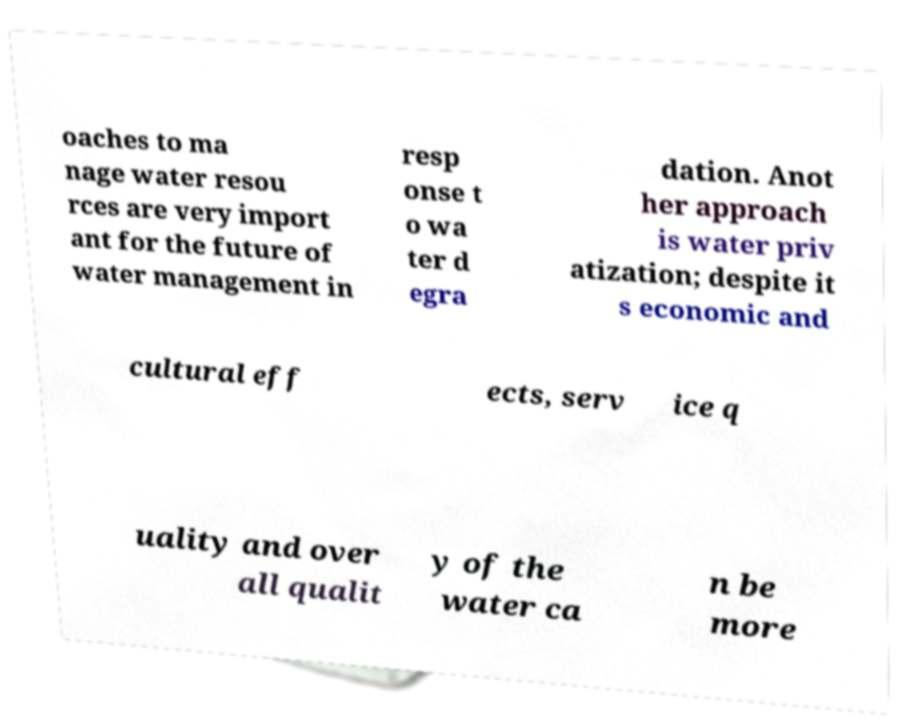Please identify and transcribe the text found in this image. oaches to ma nage water resou rces are very import ant for the future of water management in resp onse t o wa ter d egra dation. Anot her approach is water priv atization; despite it s economic and cultural eff ects, serv ice q uality and over all qualit y of the water ca n be more 